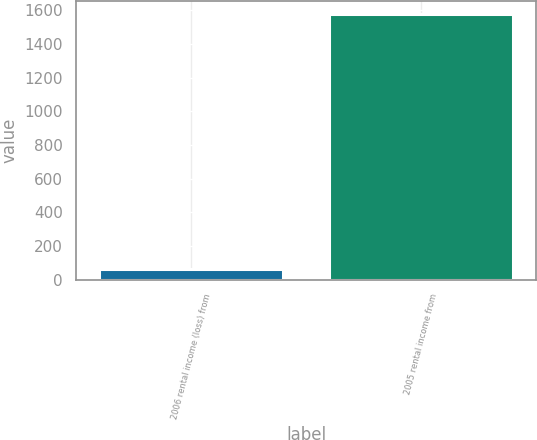Convert chart to OTSL. <chart><loc_0><loc_0><loc_500><loc_500><bar_chart><fcel>2006 rental income (loss) from<fcel>2005 rental income from<nl><fcel>64<fcel>1577<nl></chart> 